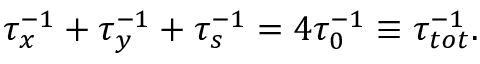<formula> <loc_0><loc_0><loc_500><loc_500>\begin{array} { r } { \tau _ { x } ^ { - 1 } + \tau _ { y } ^ { - 1 } + \tau _ { s } ^ { - 1 } = 4 \tau _ { 0 } ^ { - 1 } \equiv \tau _ { t o t } ^ { - 1 } . } \end{array}</formula> 